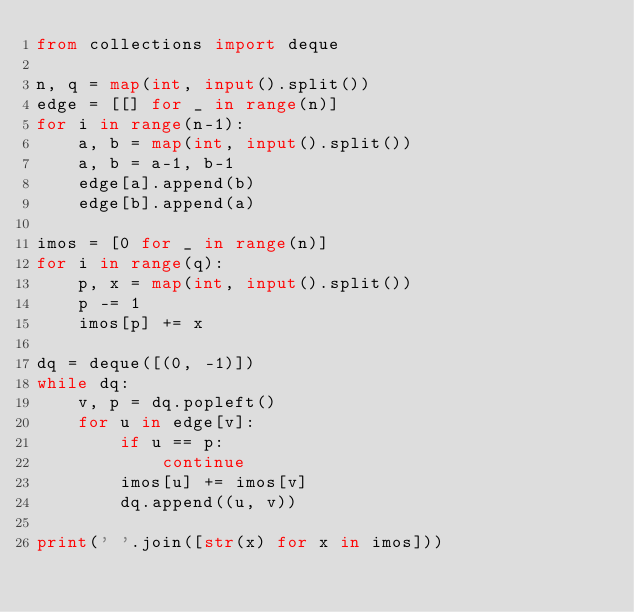<code> <loc_0><loc_0><loc_500><loc_500><_Python_>from collections import deque

n, q = map(int, input().split())
edge = [[] for _ in range(n)]
for i in range(n-1):
    a, b = map(int, input().split())
    a, b = a-1, b-1
    edge[a].append(b)
    edge[b].append(a)

imos = [0 for _ in range(n)]
for i in range(q):
    p, x = map(int, input().split())
    p -= 1
    imos[p] += x

dq = deque([(0, -1)])
while dq:
    v, p = dq.popleft()
    for u in edge[v]:
        if u == p:
            continue
        imos[u] += imos[v]
        dq.append((u, v))

print(' '.join([str(x) for x in imos]))
</code> 